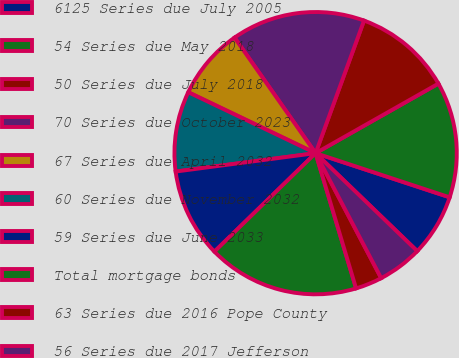Convert chart. <chart><loc_0><loc_0><loc_500><loc_500><pie_chart><fcel>6125 Series due July 2005<fcel>54 Series due May 2018<fcel>50 Series due July 2018<fcel>70 Series due October 2023<fcel>67 Series due April 2032<fcel>60 Series due November 2032<fcel>59 Series due June 2033<fcel>Total mortgage bonds<fcel>63 Series due 2016 Pope County<fcel>56 Series due 2017 Jefferson<nl><fcel>7.14%<fcel>13.26%<fcel>11.22%<fcel>15.3%<fcel>8.16%<fcel>9.18%<fcel>10.2%<fcel>17.34%<fcel>3.06%<fcel>5.1%<nl></chart> 